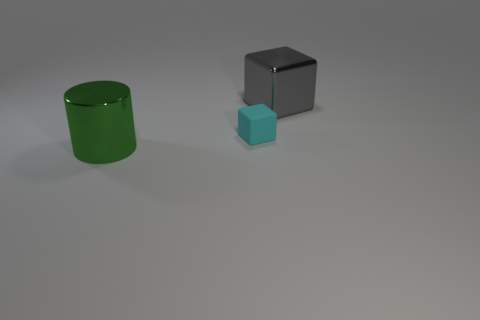Is there a matte object that has the same size as the matte block?
Offer a very short reply. No. What material is the gray block that is the same size as the green shiny object?
Make the answer very short. Metal. Do the cyan cube and the metallic thing behind the green metallic cylinder have the same size?
Offer a terse response. No. There is a cube that is in front of the large gray object; what is it made of?
Offer a terse response. Rubber. Are there the same number of big shiny blocks that are behind the gray metallic object and cyan objects?
Your response must be concise. No. Do the green cylinder and the cyan rubber thing have the same size?
Provide a succinct answer. No. There is a block in front of the metallic thing that is right of the big green cylinder; are there any large blocks that are to the left of it?
Offer a terse response. No. There is a cyan object that is the same shape as the gray metallic thing; what is its material?
Offer a very short reply. Rubber. What number of cyan things are to the right of the large object to the right of the green metal thing?
Provide a short and direct response. 0. There is a cube that is left of the big thing that is right of the large metallic object that is in front of the large gray shiny thing; what is its size?
Offer a terse response. Small. 